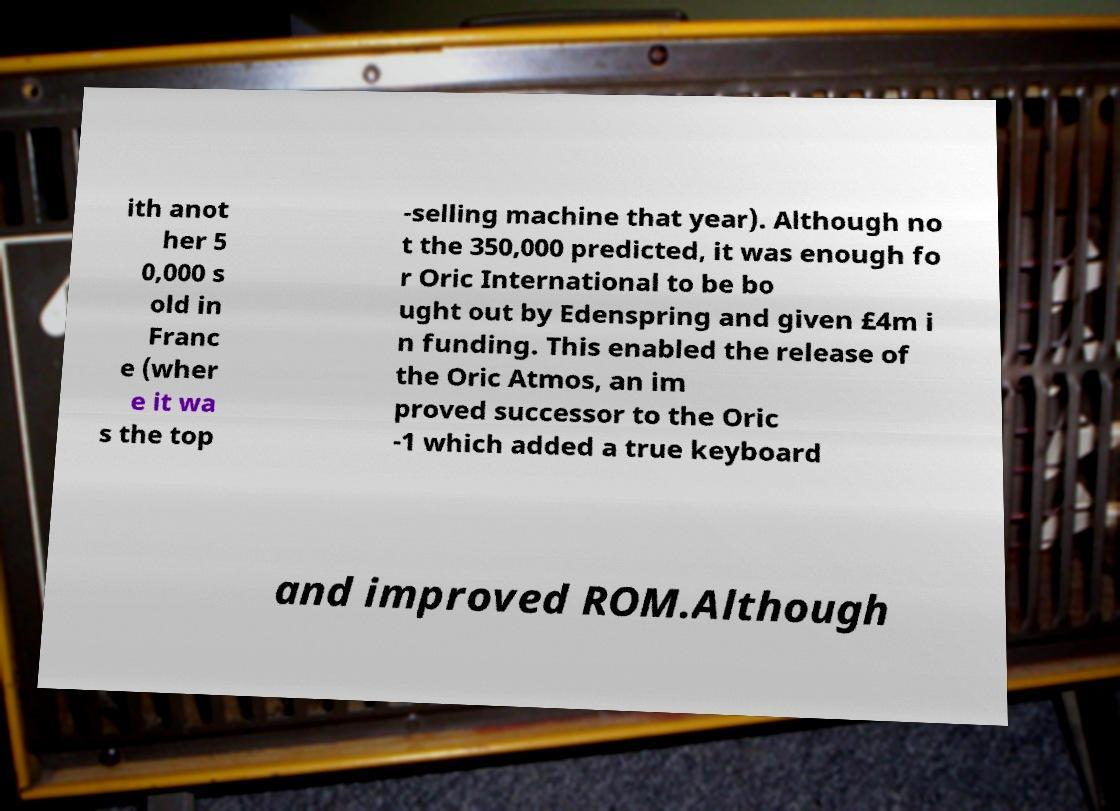For documentation purposes, I need the text within this image transcribed. Could you provide that? ith anot her 5 0,000 s old in Franc e (wher e it wa s the top -selling machine that year). Although no t the 350,000 predicted, it was enough fo r Oric International to be bo ught out by Edenspring and given £4m i n funding. This enabled the release of the Oric Atmos, an im proved successor to the Oric -1 which added a true keyboard and improved ROM.Although 